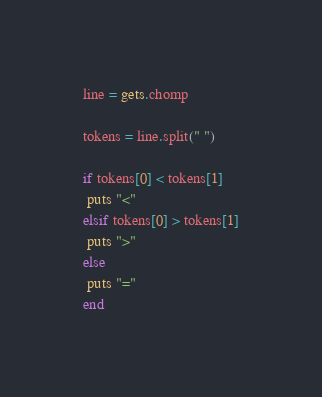<code> <loc_0><loc_0><loc_500><loc_500><_Ruby_>line = gets.chomp

tokens = line.split(" ")

if tokens[0] < tokens[1]
 puts "<"
elsif tokens[0] > tokens[1]
 puts ">"
else
 puts "="
end</code> 